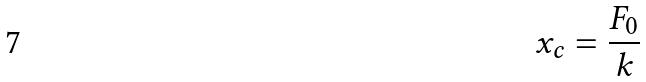Convert formula to latex. <formula><loc_0><loc_0><loc_500><loc_500>x _ { c } = \frac { F _ { 0 } } { k }</formula> 